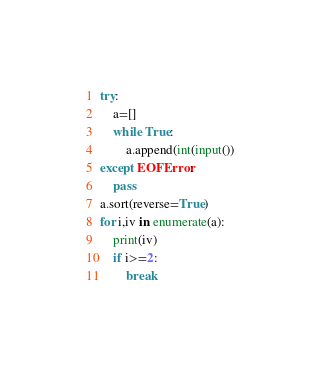Convert code to text. <code><loc_0><loc_0><loc_500><loc_500><_Python_>try:
    a=[]
    while True:
        a.append(int(input())
except EOFError:
    pass
a.sort(reverse=True)
for i,iv in enumerate(a):
    print(iv)
    if i>=2:
        break</code> 